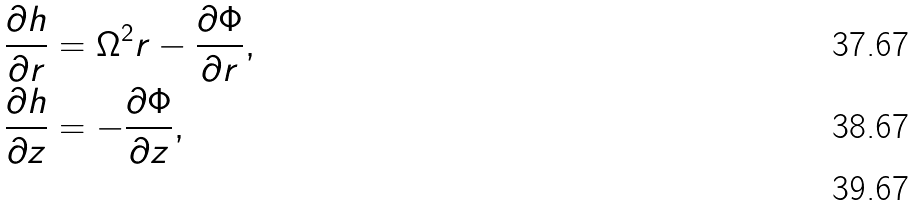<formula> <loc_0><loc_0><loc_500><loc_500>& \frac { \partial h } { \partial r } = \Omega ^ { 2 } r - \frac { \partial \Phi } { \partial r } , \\ & \frac { \partial h } { \partial z } = - \frac { \partial \Phi } { \partial z } , \\</formula> 